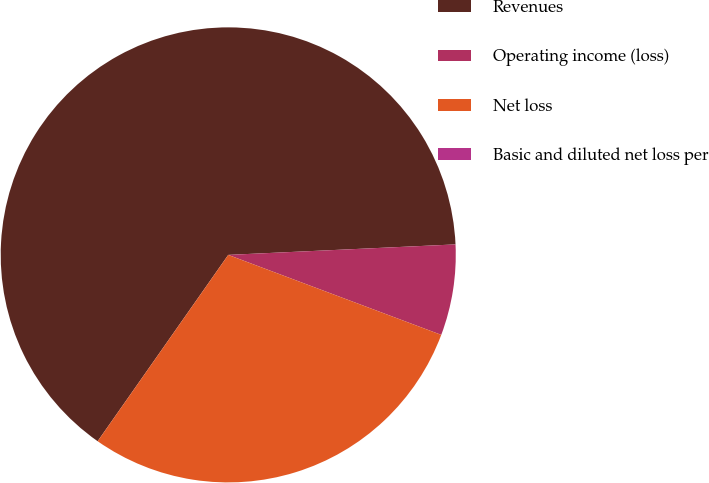Convert chart to OTSL. <chart><loc_0><loc_0><loc_500><loc_500><pie_chart><fcel>Revenues<fcel>Operating income (loss)<fcel>Net loss<fcel>Basic and diluted net loss per<nl><fcel>64.53%<fcel>6.45%<fcel>29.01%<fcel>0.0%<nl></chart> 